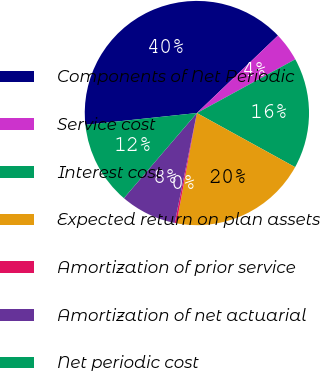<chart> <loc_0><loc_0><loc_500><loc_500><pie_chart><fcel>Components of Net Periodic<fcel>Service cost<fcel>Interest cost<fcel>Expected return on plan assets<fcel>Amortization of prior service<fcel>Amortization of net actuarial<fcel>Net periodic cost<nl><fcel>39.54%<fcel>4.18%<fcel>15.97%<fcel>19.9%<fcel>0.26%<fcel>8.11%<fcel>12.04%<nl></chart> 